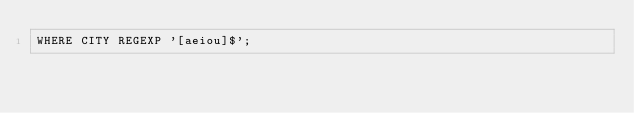Convert code to text. <code><loc_0><loc_0><loc_500><loc_500><_SQL_>WHERE CITY REGEXP '[aeiou]$';
</code> 